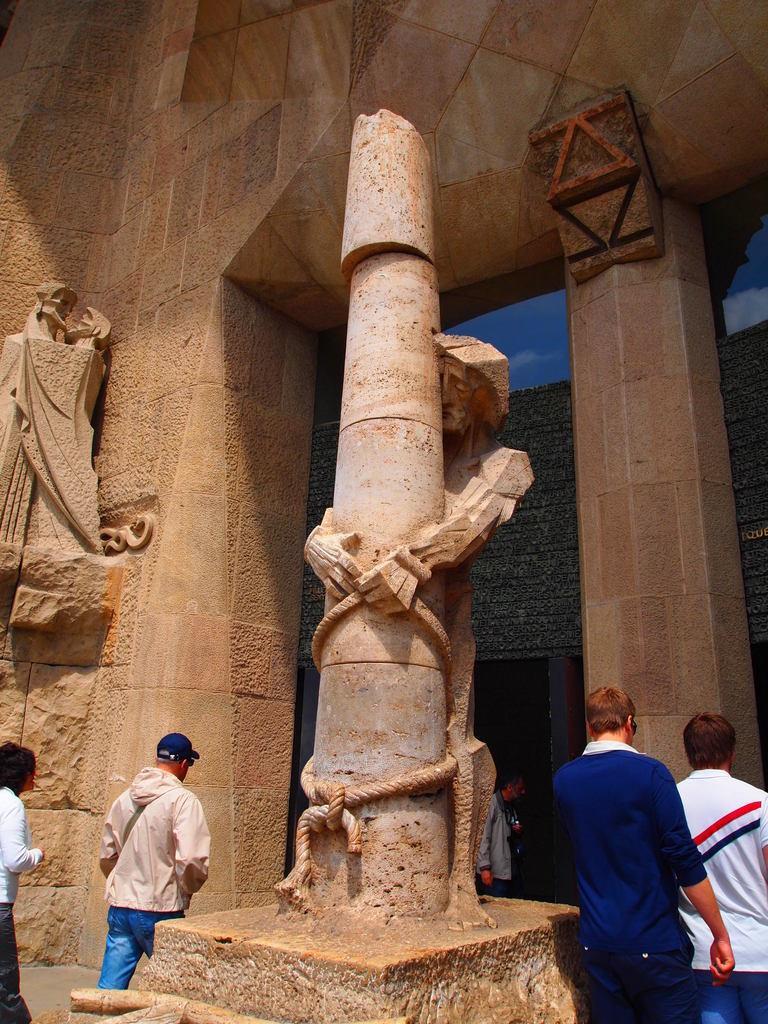Describe this image in one or two sentences. In this image we can see a building and there is a pillar and a few sculptures. On the building we can see a glass and in the glass we can see the reflection of a wall and the sky. At the bottom we can see few persons. 